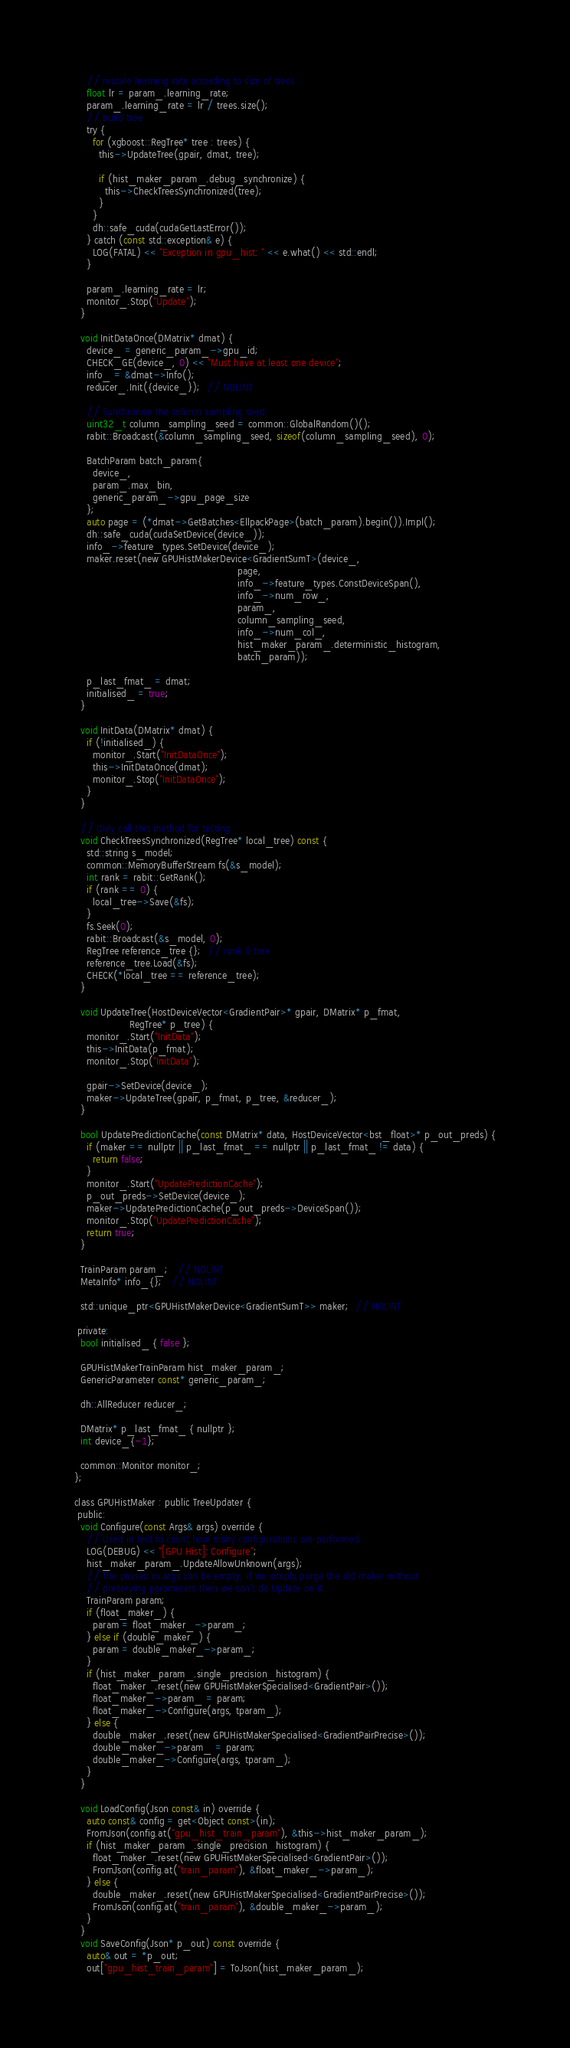<code> <loc_0><loc_0><loc_500><loc_500><_Cuda_>    // rescale learning rate according to size of trees
    float lr = param_.learning_rate;
    param_.learning_rate = lr / trees.size();
    // build tree
    try {
      for (xgboost::RegTree* tree : trees) {
        this->UpdateTree(gpair, dmat, tree);

        if (hist_maker_param_.debug_synchronize) {
          this->CheckTreesSynchronized(tree);
        }
      }
      dh::safe_cuda(cudaGetLastError());
    } catch (const std::exception& e) {
      LOG(FATAL) << "Exception in gpu_hist: " << e.what() << std::endl;
    }

    param_.learning_rate = lr;
    monitor_.Stop("Update");
  }

  void InitDataOnce(DMatrix* dmat) {
    device_ = generic_param_->gpu_id;
    CHECK_GE(device_, 0) << "Must have at least one device";
    info_ = &dmat->Info();
    reducer_.Init({device_});  // NOLINT

    // Synchronise the column sampling seed
    uint32_t column_sampling_seed = common::GlobalRandom()();
    rabit::Broadcast(&column_sampling_seed, sizeof(column_sampling_seed), 0);

    BatchParam batch_param{
      device_,
      param_.max_bin,
      generic_param_->gpu_page_size
    };
    auto page = (*dmat->GetBatches<EllpackPage>(batch_param).begin()).Impl();
    dh::safe_cuda(cudaSetDevice(device_));
    info_->feature_types.SetDevice(device_);
    maker.reset(new GPUHistMakerDevice<GradientSumT>(device_,
                                                     page,
                                                     info_->feature_types.ConstDeviceSpan(),
                                                     info_->num_row_,
                                                     param_,
                                                     column_sampling_seed,
                                                     info_->num_col_,
                                                     hist_maker_param_.deterministic_histogram,
                                                     batch_param));

    p_last_fmat_ = dmat;
    initialised_ = true;
  }

  void InitData(DMatrix* dmat) {
    if (!initialised_) {
      monitor_.Start("InitDataOnce");
      this->InitDataOnce(dmat);
      monitor_.Stop("InitDataOnce");
    }
  }

  // Only call this method for testing
  void CheckTreesSynchronized(RegTree* local_tree) const {
    std::string s_model;
    common::MemoryBufferStream fs(&s_model);
    int rank = rabit::GetRank();
    if (rank == 0) {
      local_tree->Save(&fs);
    }
    fs.Seek(0);
    rabit::Broadcast(&s_model, 0);
    RegTree reference_tree {};  // rank 0 tree
    reference_tree.Load(&fs);
    CHECK(*local_tree == reference_tree);
  }

  void UpdateTree(HostDeviceVector<GradientPair>* gpair, DMatrix* p_fmat,
                  RegTree* p_tree) {
    monitor_.Start("InitData");
    this->InitData(p_fmat);
    monitor_.Stop("InitData");

    gpair->SetDevice(device_);
    maker->UpdateTree(gpair, p_fmat, p_tree, &reducer_);
  }

  bool UpdatePredictionCache(const DMatrix* data, HostDeviceVector<bst_float>* p_out_preds) {
    if (maker == nullptr || p_last_fmat_ == nullptr || p_last_fmat_ != data) {
      return false;
    }
    monitor_.Start("UpdatePredictionCache");
    p_out_preds->SetDevice(device_);
    maker->UpdatePredictionCache(p_out_preds->DeviceSpan());
    monitor_.Stop("UpdatePredictionCache");
    return true;
  }

  TrainParam param_;   // NOLINT
  MetaInfo* info_{};   // NOLINT

  std::unique_ptr<GPUHistMakerDevice<GradientSumT>> maker;  // NOLINT

 private:
  bool initialised_ { false };

  GPUHistMakerTrainParam hist_maker_param_;
  GenericParameter const* generic_param_;

  dh::AllReducer reducer_;

  DMatrix* p_last_fmat_ { nullptr };
  int device_{-1};

  common::Monitor monitor_;
};

class GPUHistMaker : public TreeUpdater {
 public:
  void Configure(const Args& args) override {
    // Used in test to count how many configurations are performed
    LOG(DEBUG) << "[GPU Hist]: Configure";
    hist_maker_param_.UpdateAllowUnknown(args);
    // The passed in args can be empty, if we simply purge the old maker without
    // preserving parameters then we can't do Update on it.
    TrainParam param;
    if (float_maker_) {
      param = float_maker_->param_;
    } else if (double_maker_) {
      param = double_maker_->param_;
    }
    if (hist_maker_param_.single_precision_histogram) {
      float_maker_.reset(new GPUHistMakerSpecialised<GradientPair>());
      float_maker_->param_ = param;
      float_maker_->Configure(args, tparam_);
    } else {
      double_maker_.reset(new GPUHistMakerSpecialised<GradientPairPrecise>());
      double_maker_->param_ = param;
      double_maker_->Configure(args, tparam_);
    }
  }

  void LoadConfig(Json const& in) override {
    auto const& config = get<Object const>(in);
    FromJson(config.at("gpu_hist_train_param"), &this->hist_maker_param_);
    if (hist_maker_param_.single_precision_histogram) {
      float_maker_.reset(new GPUHistMakerSpecialised<GradientPair>());
      FromJson(config.at("train_param"), &float_maker_->param_);
    } else {
      double_maker_.reset(new GPUHistMakerSpecialised<GradientPairPrecise>());
      FromJson(config.at("train_param"), &double_maker_->param_);
    }
  }
  void SaveConfig(Json* p_out) const override {
    auto& out = *p_out;
    out["gpu_hist_train_param"] = ToJson(hist_maker_param_);</code> 